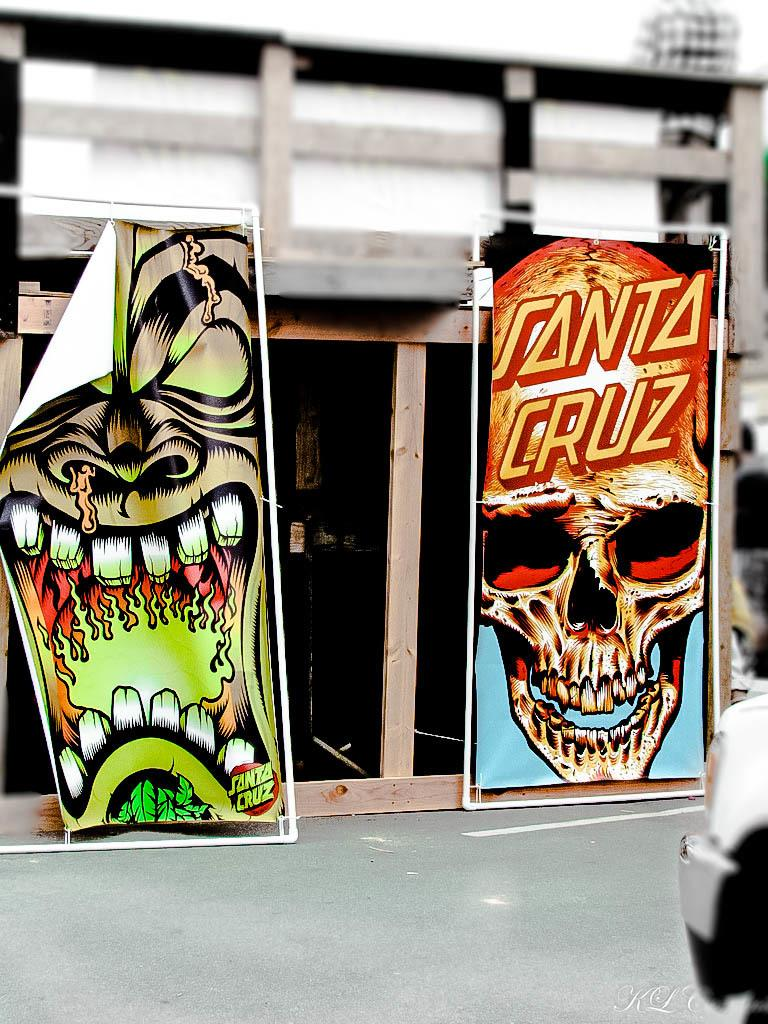What type of building is shown in the image? There is a building with glass doors in the image. Are there any specific features on the building? The building has two big posters. What is depicted on the posters? The posters have skull images. What historical event is being commemorated by the posters in the image? There is no indication of any historical event being commemorated by the posters in the image. 